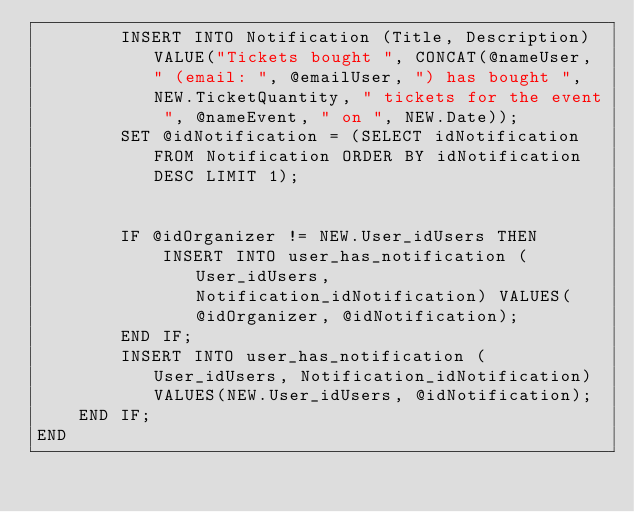Convert code to text. <code><loc_0><loc_0><loc_500><loc_500><_SQL_>		INSERT INTO Notification (Title, Description) VALUE("Tickets bought ", CONCAT(@nameUser, " (email: ", @emailUser, ") has bought ", NEW.TicketQuantity, " tickets for the event ", @nameEvent, " on ", NEW.Date));
		SET @idNotification = (SELECT idNotification FROM Notification ORDER BY idNotification DESC LIMIT 1);

		
        IF @idOrganizer != NEW.User_idUsers THEN
			INSERT INTO user_has_notification (User_idUsers, Notification_idNotification) VALUES(@idOrganizer, @idNotification);
        END IF;
		INSERT INTO user_has_notification (User_idUsers, Notification_idNotification) VALUES(NEW.User_idUsers, @idNotification);
	END IF;
END</code> 